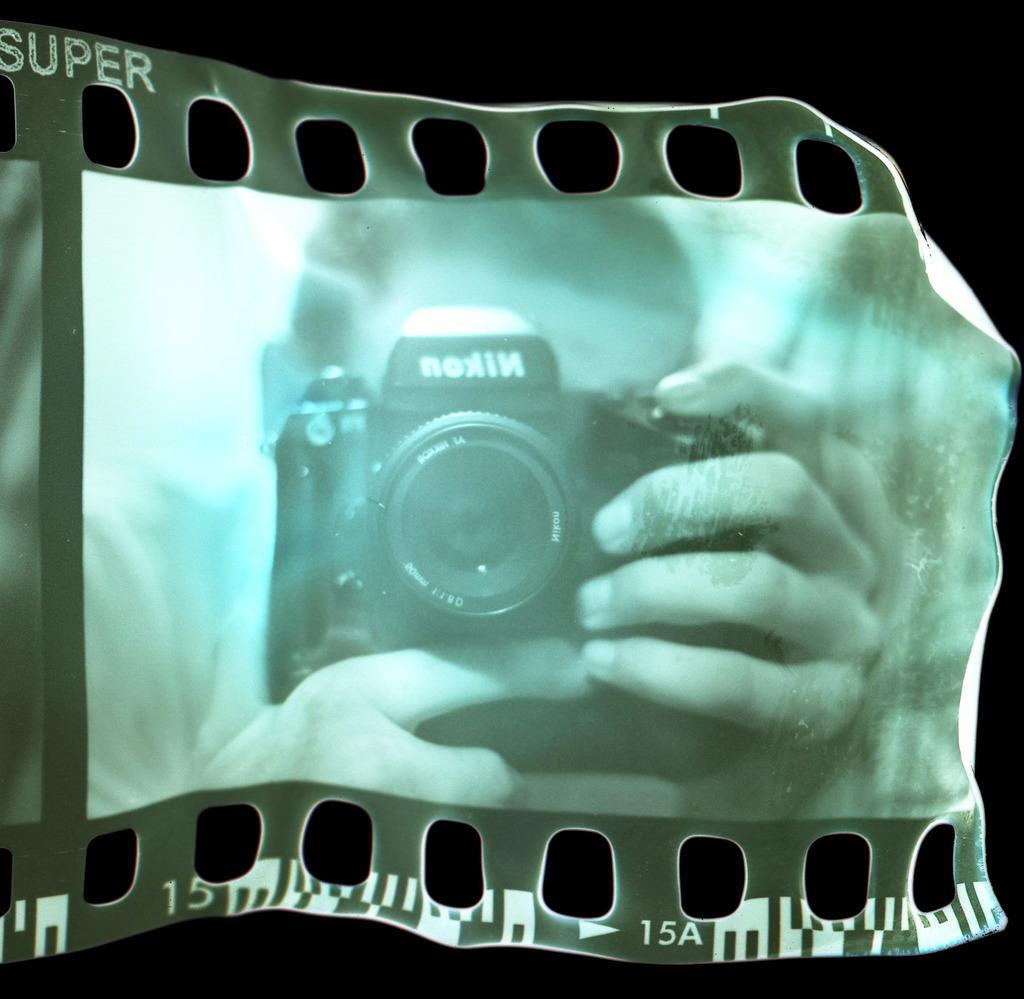What is visible in the image due to a reflection? There is a reflection of a person holding a camera in the image. What is the person holding in the image? The person is holding a camera. Is there any text visible on the camera? Yes, some text is written on the camera. How many ducks are visible in the image? There are no ducks present in the image. What type of bit is being used by the person holding the camera in the image? There is no indication of a bit being used by the person holding the camera in the image. 